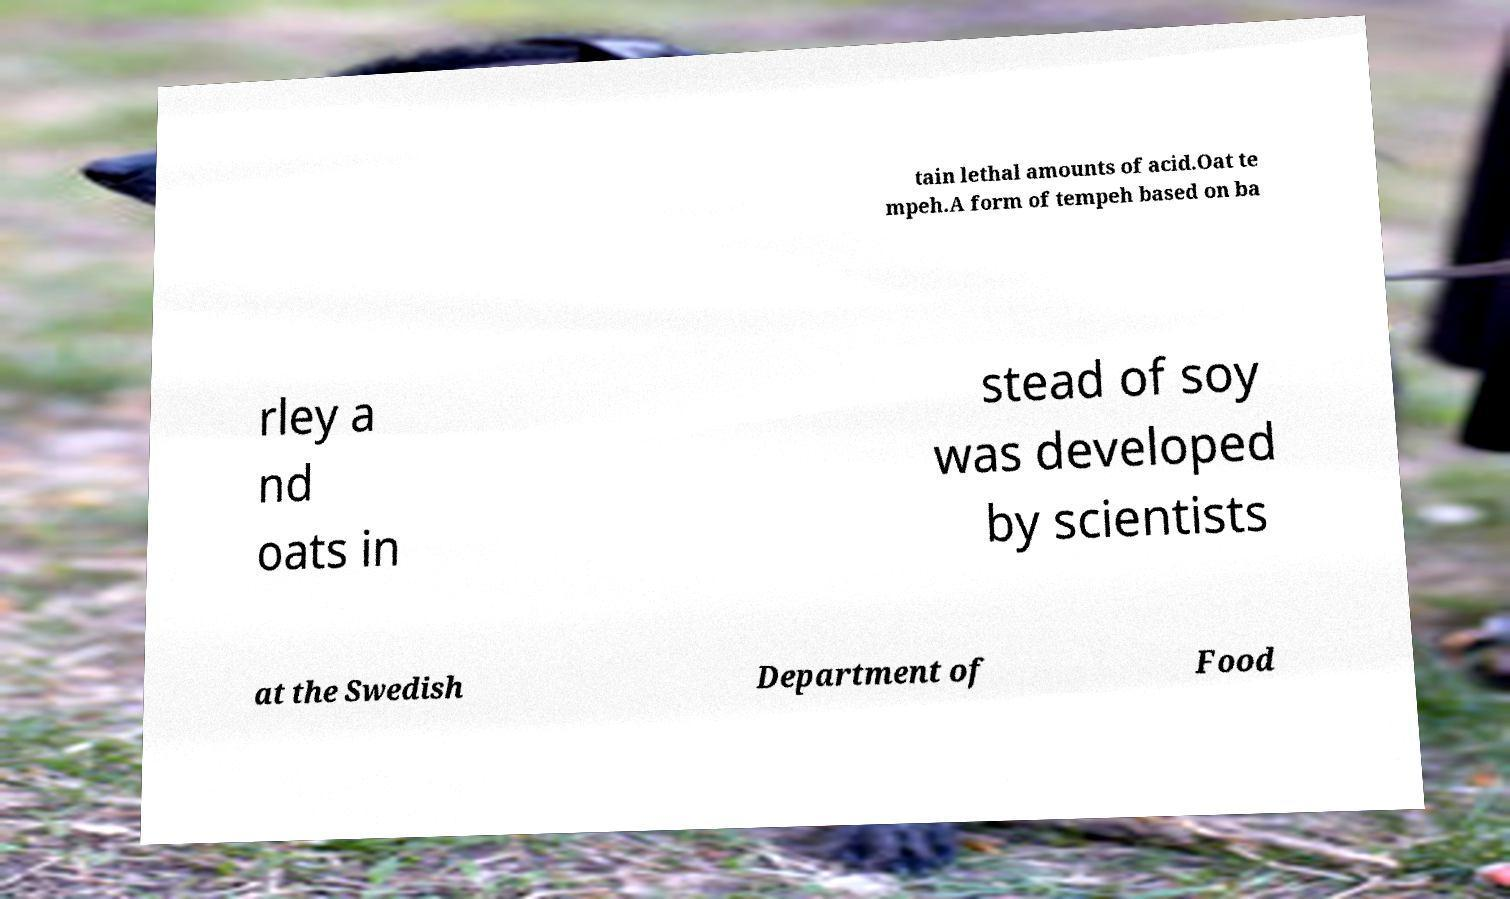For documentation purposes, I need the text within this image transcribed. Could you provide that? tain lethal amounts of acid.Oat te mpeh.A form of tempeh based on ba rley a nd oats in stead of soy was developed by scientists at the Swedish Department of Food 